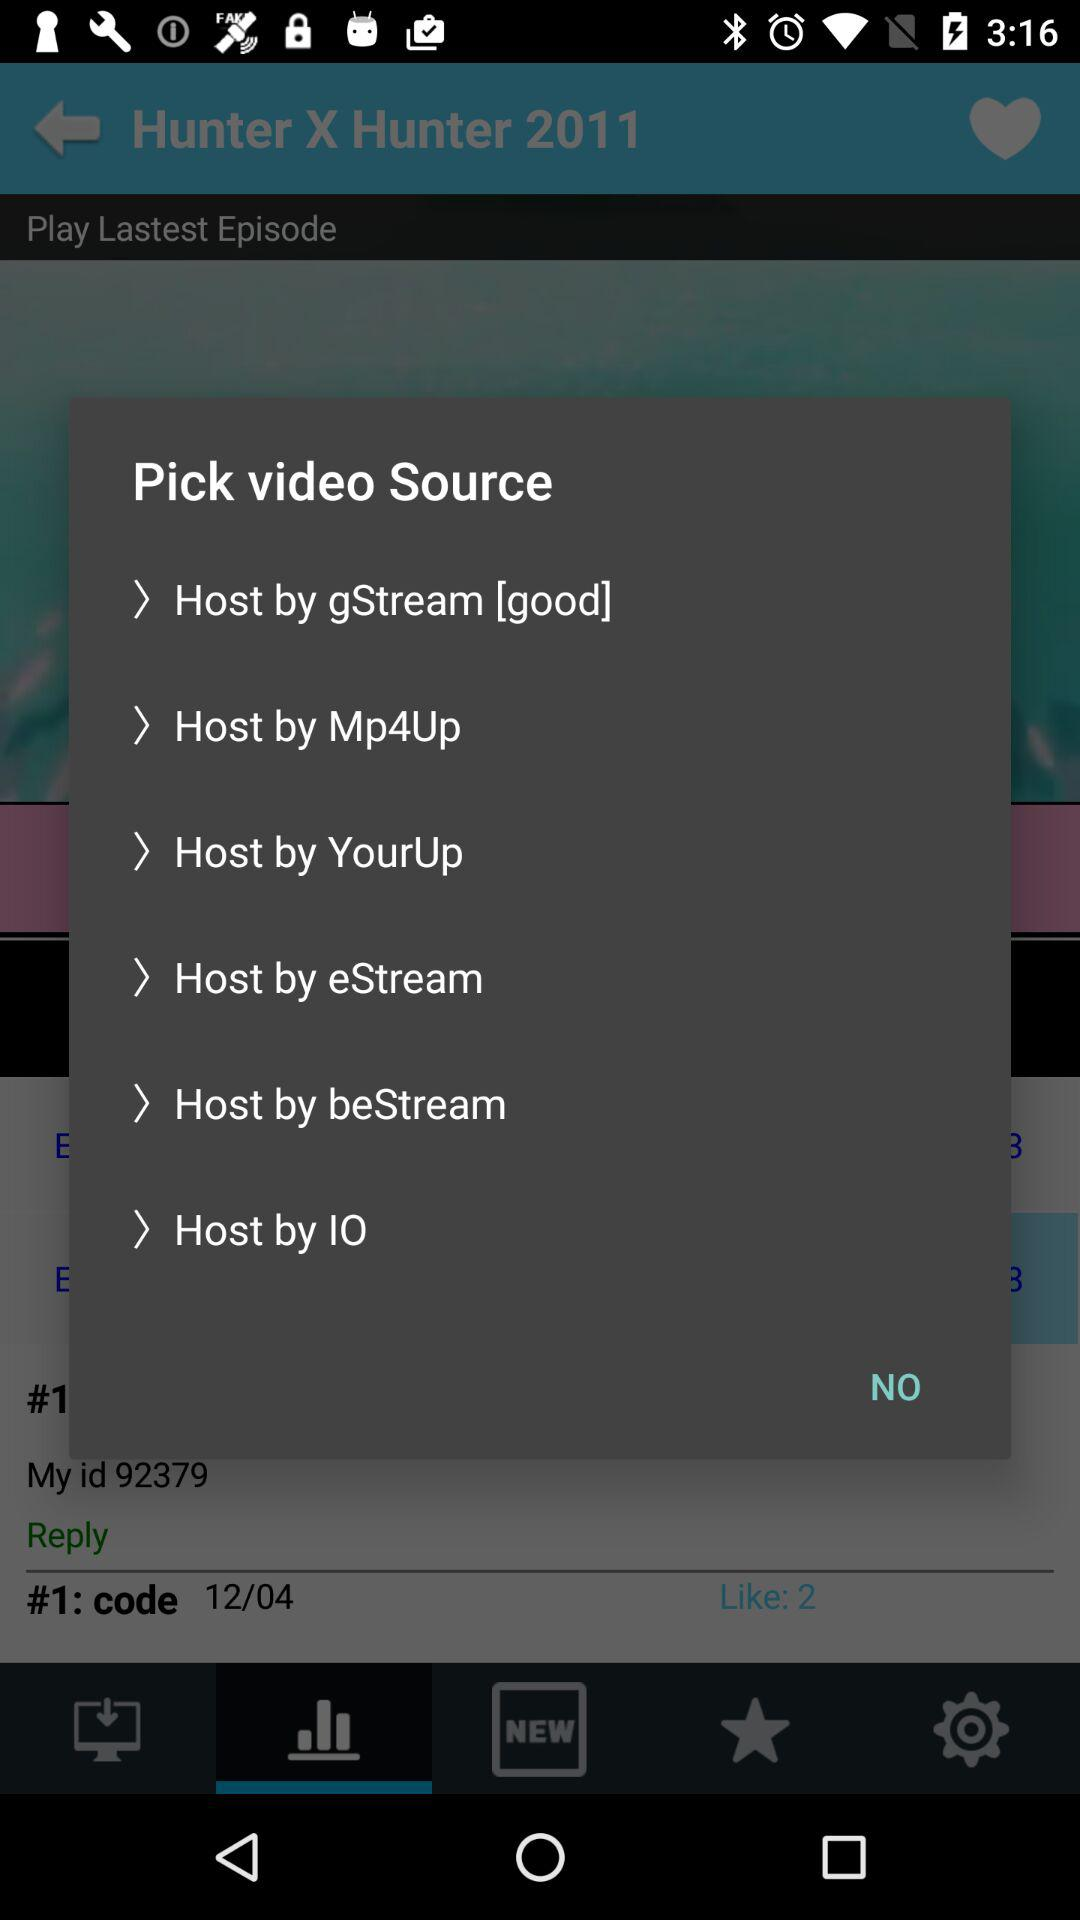How many video sources are there?
Answer the question using a single word or phrase. 6 